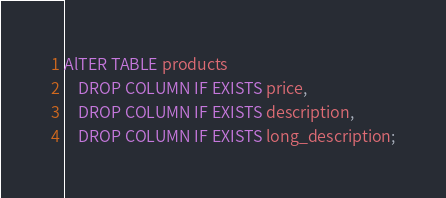Convert code to text. <code><loc_0><loc_0><loc_500><loc_500><_SQL_>AlTER TABLE products
    DROP COLUMN IF EXISTS price,
    DROP COLUMN IF EXISTS description,
    DROP COLUMN IF EXISTS long_description;</code> 